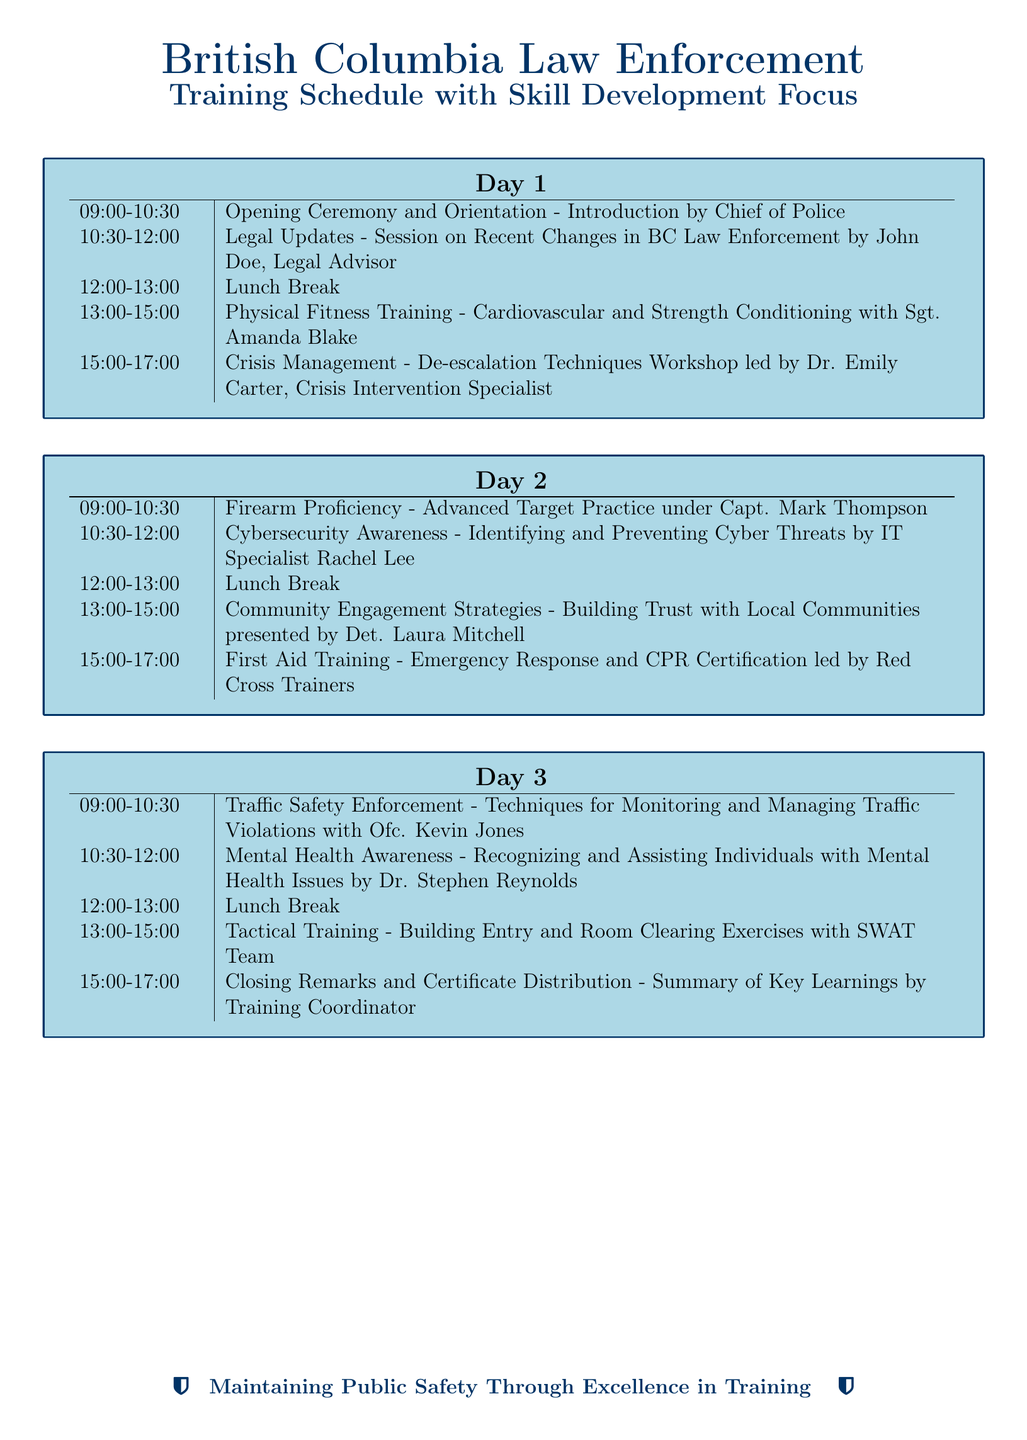What is the title of the document? The title is typically located at the top of the document, which states the purpose and focus clearly.
Answer: Training Schedule with Skill Development Focus Who conducted the legal updates session? The name of the presenter for the legal updates session is listed in the schedule portion of the document.
Answer: John Doe What time does Day 1 start? The starting time for Day 1 is indicated in the schedule as the first listed time.
Answer: 09:00 How many sessions are there on Day 2? By counting the listed activities for Day 2, we can determine the number of sessions.
Answer: 5 What is the focus of the last session on Day 3? The focus of the last session is indicated by its title in the training schedule.
Answer: Certificate Distribution Who led the first aid training? The instructor for the first aid training session is identified in the document.
Answer: Red Cross Trainers Which topic involves community engagement? The session focusing on community engagement strategies can be found by examining the Day 2 schedule.
Answer: Community Engagement Strategies What time is the lunch break on Day 1? The timing for the lunch break is explicitly mentioned in the schedule for Day 1.
Answer: 12:00-13:00 What is the main theme of the training? The overall aim or message of the training is summarized at the end of the document, encapsulating the essence of the training.
Answer: Maintaining Public Safety Through Excellence in Training 